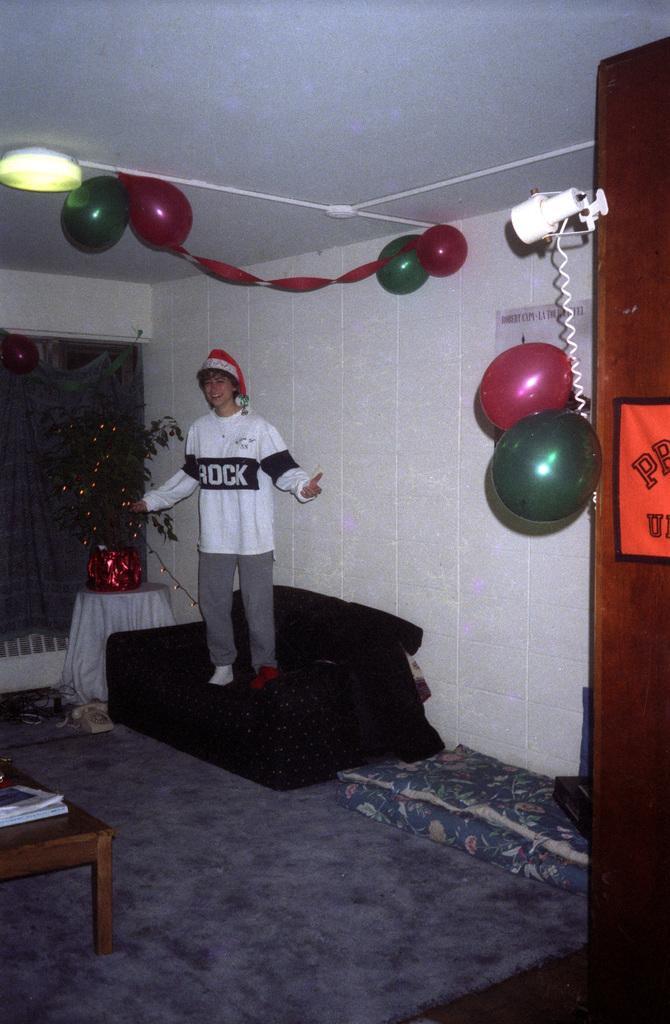In one or two sentences, can you explain what this image depicts? In the middle of the image, there is a person in white color T-shirt, smiling and standing on a sofa which is on the floor. On the right side, there are balloons attached to a door. On the left side, there are some objects on a table. In the background, there is a curtain and there is a white wall. 